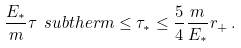<formula> <loc_0><loc_0><loc_500><loc_500>\frac { E _ { * } } { m } \tau \ s u b { t h e r m } \leq \tau _ { * } \leq \frac { 5 } { 4 } \frac { m } { E _ { * } } r _ { + } \, .</formula> 